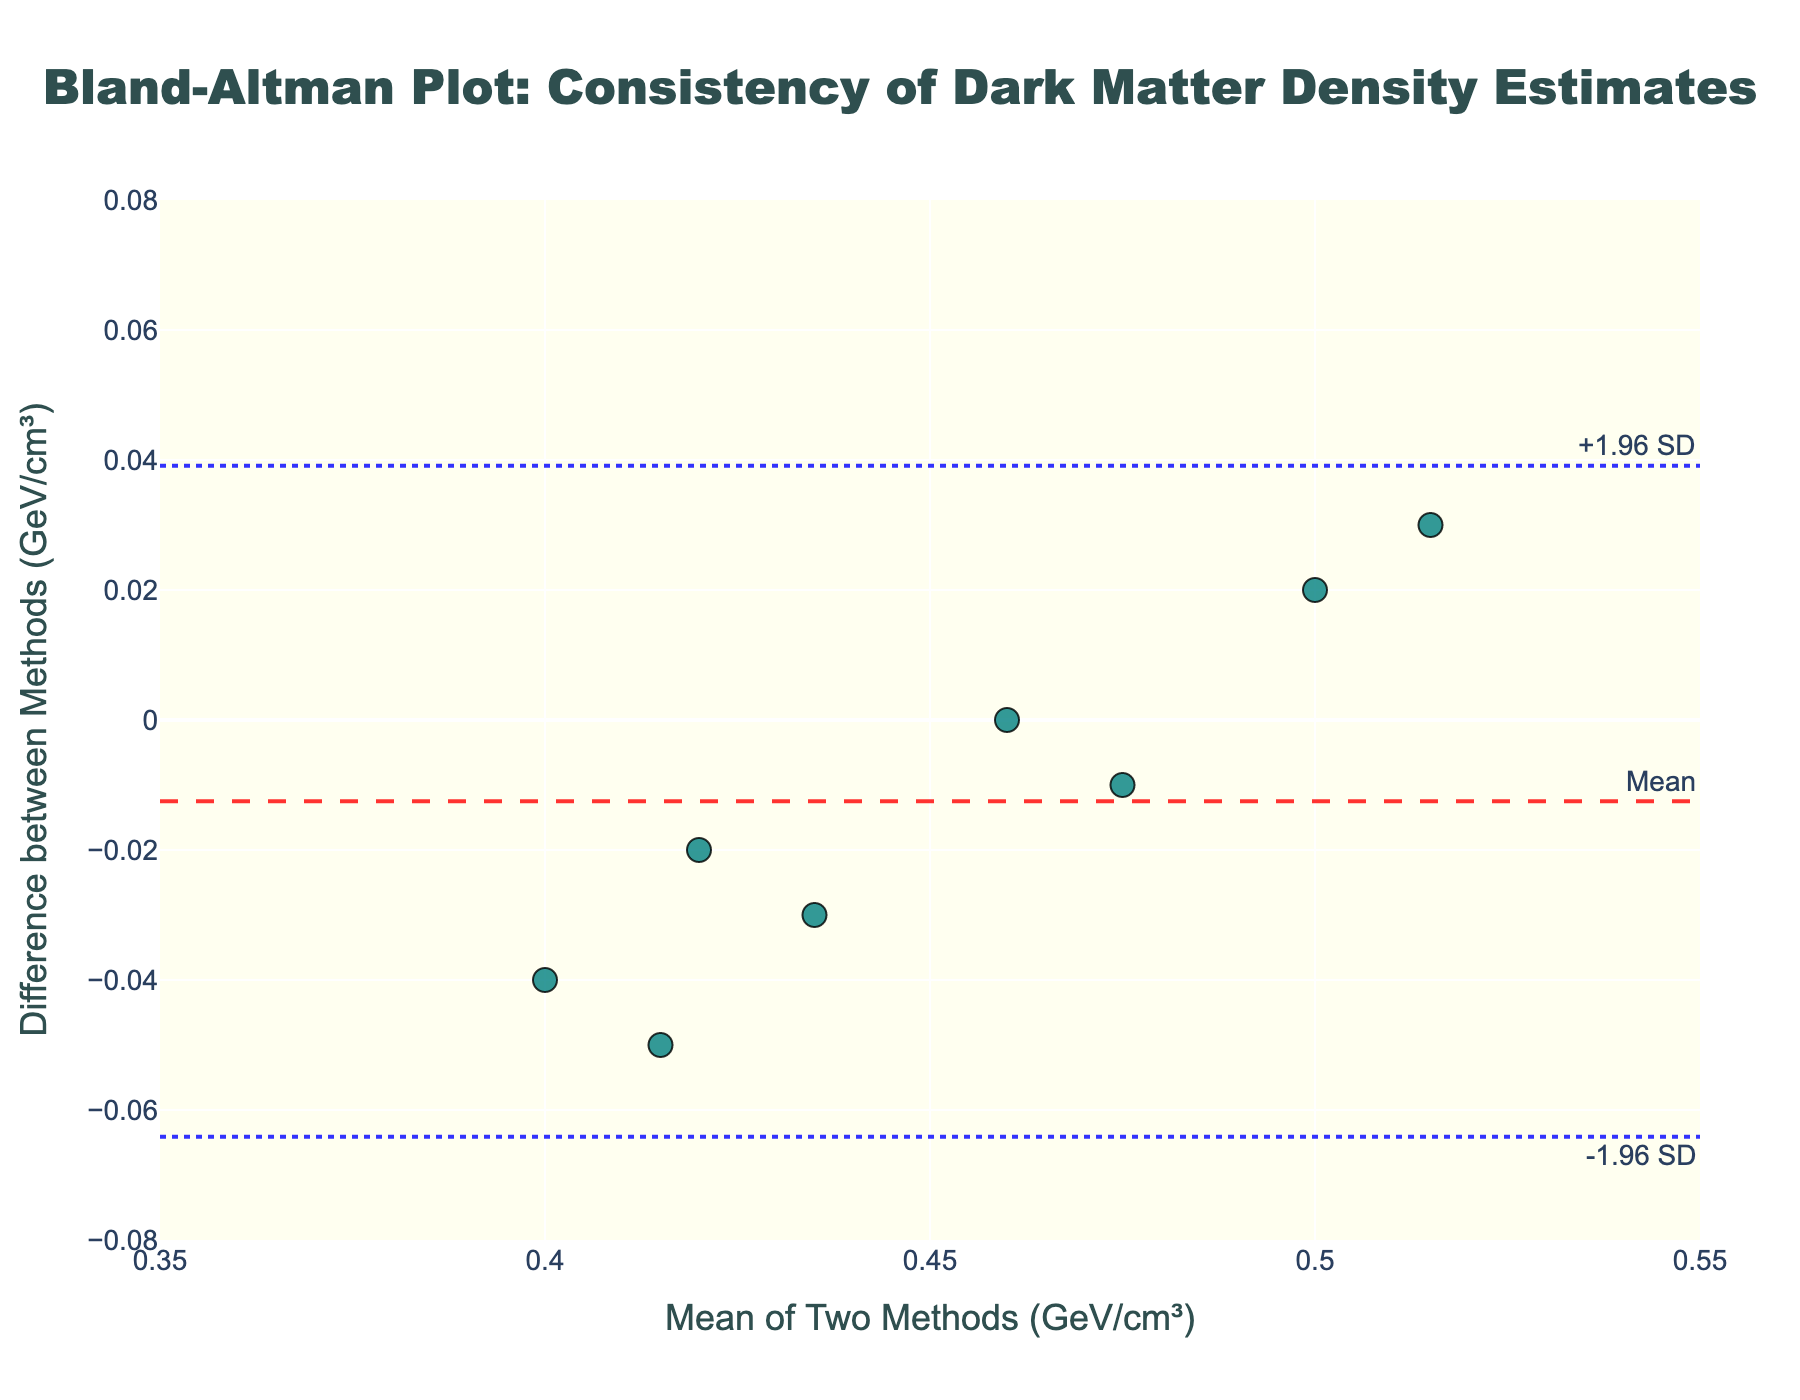What's the title of the plot? The title of the plot is displayed at the top center of the figure in large font.
Answer: Bland-Altman Plot: Consistency of Dark Matter Density Estimates What are the x-axis and y-axis labels? The x-axis label is placed horizontally below the x-axis, and the y-axis label is placed vertically to the left of the y-axis.
Answer: The x-axis is "Mean of Two Methods (GeV/cm³)" and the y-axis is "Difference between Methods (GeV/cm³)" How many data points are plotted? Each data point corresponds to a marker on the figure. By visually counting them, we determine the total number.
Answer: 8 What are the values of the mean difference and the limits of agreement? The mean difference is indicated by the dashed line in red, and the limits of agreement are indicated by dotted lines in blue. The values are also annotated next to these lines.
Answer: Mean difference: 0, Lower LOA: -0.0792, Upper LOA: 0.0792 What is the maximum value of the differences plotted? To determine this, identify the highest point marked on the y-axis.
Answer: 0.05 GeV/cm³ How do the density estimates from the two methods compare on average? By examining the mean difference line, which represents whether one method consistently estimates higher or lower densities compared to the other.
Answer: On average, there is no significant difference (Mean difference = 0) What range do the mean values of the two methods fall within? Check the horizontal range of data points on the x-axis to identify the minimum and maximum values.
Answer: 0.35 to 0.55 GeV/cm³ How does the point density distribute relative to the mean difference line? Observe the distribution pattern of the data points above and below the mean difference line.
Answer: Fairly balanced around the mean difference line Are there any outliers in the differences, and where are they located? Identify if any data points lie significantly outside the limits of agreement lines (dotted blue lines).
Answer: No, there are no outliers outside the limits of agreement Based on the plot, how consistent are the two methods in estimating dark matter density? Assess the spread of data points around the mean difference line and within the limits of agreement to gauge consistency.
Answer: The two methods are quite consistent as most points lie closely around the mean difference line and within the limits of agreement 